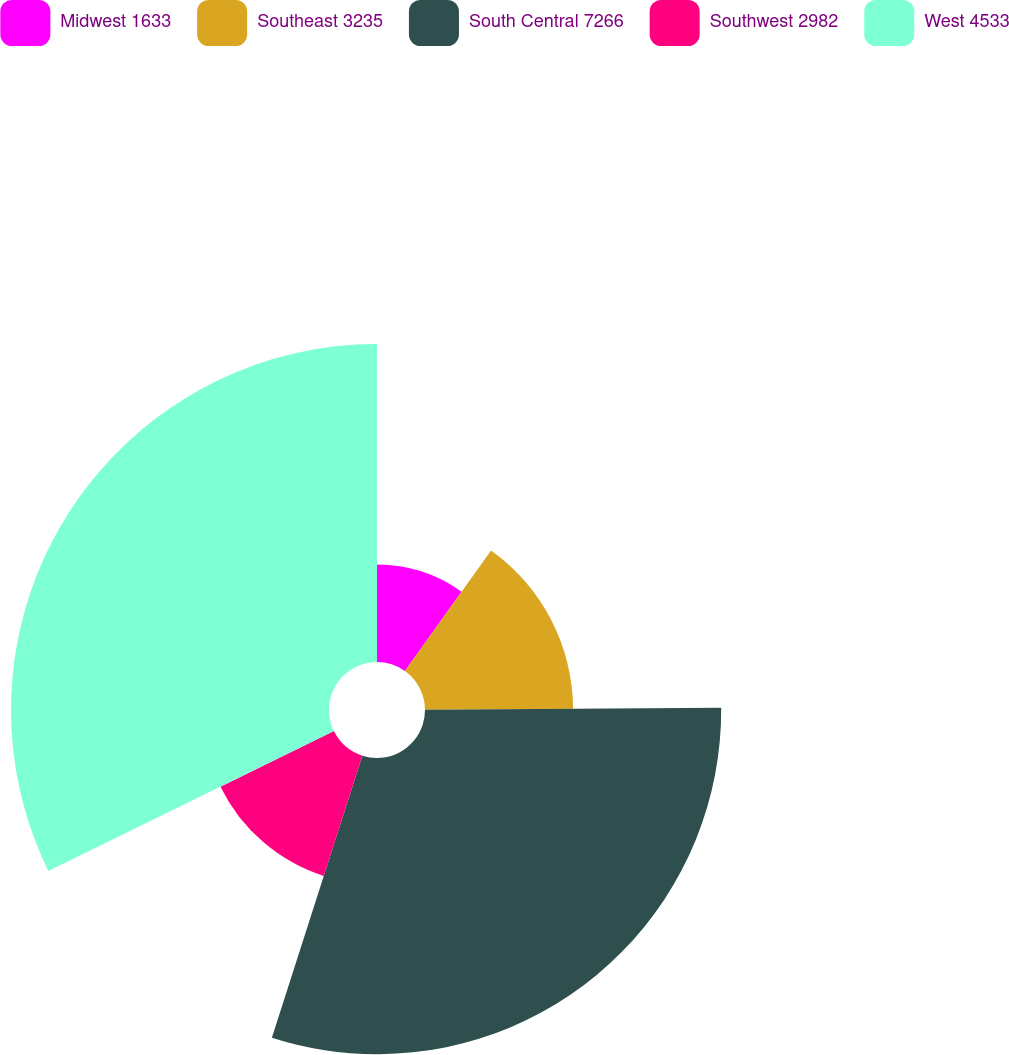Convert chart. <chart><loc_0><loc_0><loc_500><loc_500><pie_chart><fcel>Midwest 1633<fcel>Southeast 3235<fcel>South Central 7266<fcel>Southwest 2982<fcel>West 4533<nl><fcel>9.88%<fcel>15.02%<fcel>30.04%<fcel>12.81%<fcel>32.25%<nl></chart> 